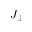<formula> <loc_0><loc_0><loc_500><loc_500>J _ { \perp }</formula> 